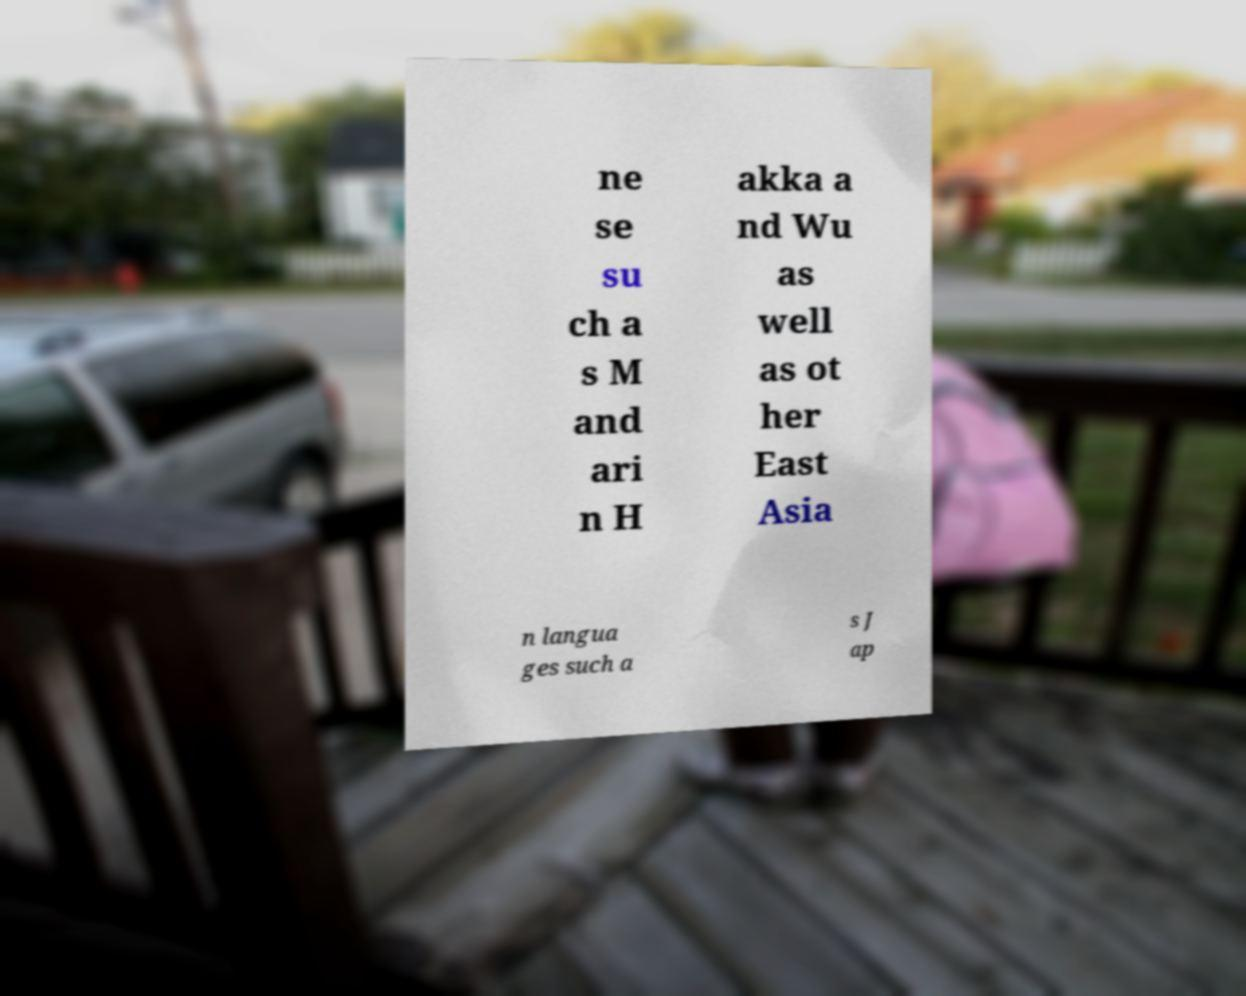Could you extract and type out the text from this image? ne se su ch a s M and ari n H akka a nd Wu as well as ot her East Asia n langua ges such a s J ap 